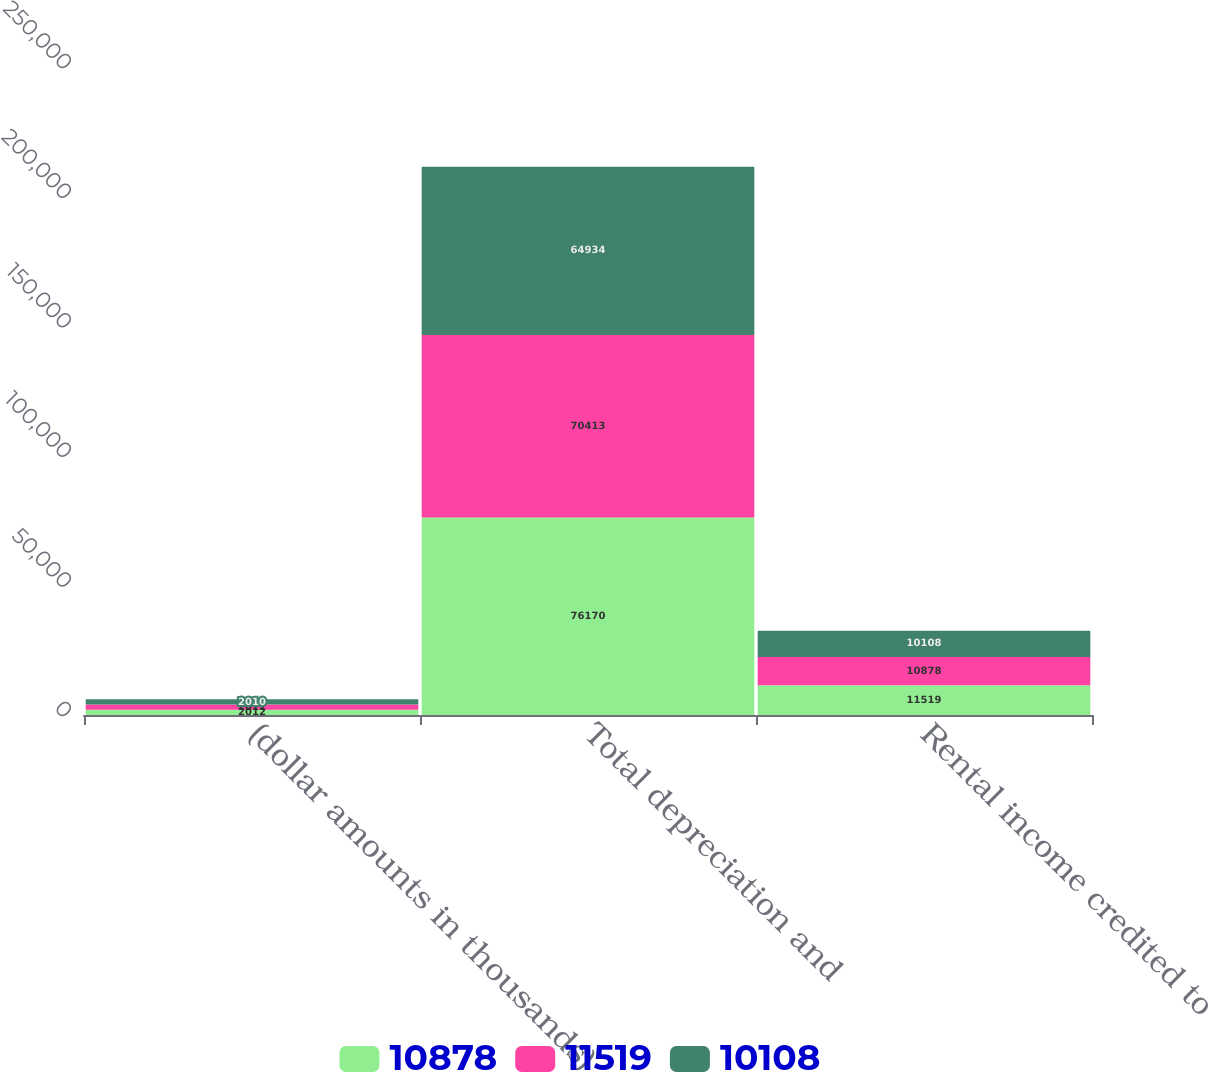<chart> <loc_0><loc_0><loc_500><loc_500><stacked_bar_chart><ecel><fcel>(dollar amounts in thousands)<fcel>Total depreciation and<fcel>Rental income credited to<nl><fcel>10878<fcel>2012<fcel>76170<fcel>11519<nl><fcel>11519<fcel>2011<fcel>70413<fcel>10878<nl><fcel>10108<fcel>2010<fcel>64934<fcel>10108<nl></chart> 